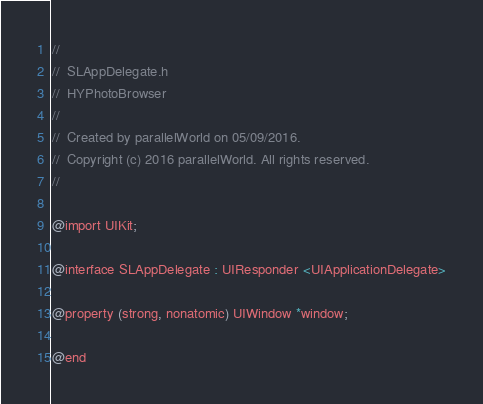<code> <loc_0><loc_0><loc_500><loc_500><_C_>//
//  SLAppDelegate.h
//  HYPhotoBrowser
//
//  Created by parallelWorld on 05/09/2016.
//  Copyright (c) 2016 parallelWorld. All rights reserved.
//

@import UIKit;

@interface SLAppDelegate : UIResponder <UIApplicationDelegate>

@property (strong, nonatomic) UIWindow *window;

@end
</code> 